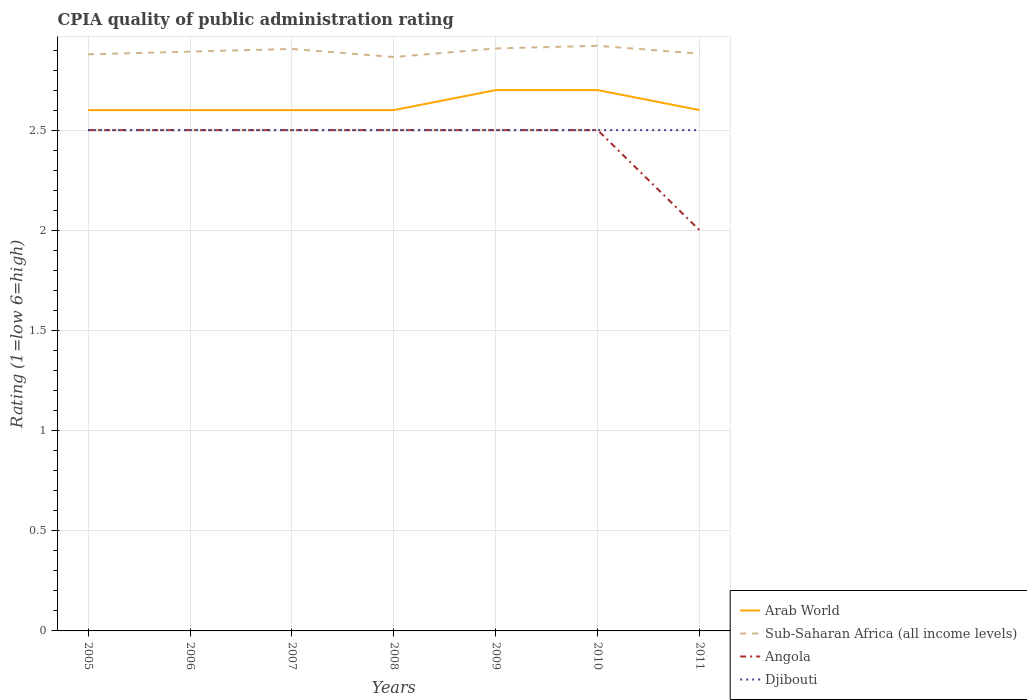How many different coloured lines are there?
Make the answer very short. 4. Is the number of lines equal to the number of legend labels?
Your answer should be compact. Yes. Across all years, what is the maximum CPIA rating in Djibouti?
Offer a very short reply. 2.5. What is the total CPIA rating in Arab World in the graph?
Ensure brevity in your answer.  0. How many lines are there?
Provide a succinct answer. 4. How are the legend labels stacked?
Offer a terse response. Vertical. What is the title of the graph?
Give a very brief answer. CPIA quality of public administration rating. Does "Middle income" appear as one of the legend labels in the graph?
Your response must be concise. No. What is the label or title of the Y-axis?
Give a very brief answer. Rating (1=low 6=high). What is the Rating (1=low 6=high) in Arab World in 2005?
Keep it short and to the point. 2.6. What is the Rating (1=low 6=high) of Sub-Saharan Africa (all income levels) in 2005?
Your answer should be compact. 2.88. What is the Rating (1=low 6=high) of Angola in 2005?
Give a very brief answer. 2.5. What is the Rating (1=low 6=high) of Djibouti in 2005?
Offer a terse response. 2.5. What is the Rating (1=low 6=high) of Arab World in 2006?
Offer a very short reply. 2.6. What is the Rating (1=low 6=high) of Sub-Saharan Africa (all income levels) in 2006?
Offer a very short reply. 2.89. What is the Rating (1=low 6=high) in Sub-Saharan Africa (all income levels) in 2007?
Offer a terse response. 2.91. What is the Rating (1=low 6=high) of Sub-Saharan Africa (all income levels) in 2008?
Your answer should be compact. 2.86. What is the Rating (1=low 6=high) of Angola in 2008?
Give a very brief answer. 2.5. What is the Rating (1=low 6=high) of Djibouti in 2008?
Your answer should be very brief. 2.5. What is the Rating (1=low 6=high) of Sub-Saharan Africa (all income levels) in 2009?
Offer a terse response. 2.91. What is the Rating (1=low 6=high) of Angola in 2009?
Offer a very short reply. 2.5. What is the Rating (1=low 6=high) in Djibouti in 2009?
Offer a terse response. 2.5. What is the Rating (1=low 6=high) of Arab World in 2010?
Your response must be concise. 2.7. What is the Rating (1=low 6=high) in Sub-Saharan Africa (all income levels) in 2010?
Keep it short and to the point. 2.92. What is the Rating (1=low 6=high) in Angola in 2010?
Provide a short and direct response. 2.5. What is the Rating (1=low 6=high) of Arab World in 2011?
Offer a terse response. 2.6. What is the Rating (1=low 6=high) in Sub-Saharan Africa (all income levels) in 2011?
Keep it short and to the point. 2.88. What is the Rating (1=low 6=high) in Djibouti in 2011?
Offer a terse response. 2.5. Across all years, what is the maximum Rating (1=low 6=high) in Sub-Saharan Africa (all income levels)?
Ensure brevity in your answer.  2.92. Across all years, what is the maximum Rating (1=low 6=high) in Djibouti?
Provide a succinct answer. 2.5. Across all years, what is the minimum Rating (1=low 6=high) of Arab World?
Provide a short and direct response. 2.6. Across all years, what is the minimum Rating (1=low 6=high) of Sub-Saharan Africa (all income levels)?
Ensure brevity in your answer.  2.86. What is the total Rating (1=low 6=high) in Sub-Saharan Africa (all income levels) in the graph?
Your answer should be compact. 20.25. What is the difference between the Rating (1=low 6=high) in Sub-Saharan Africa (all income levels) in 2005 and that in 2006?
Provide a succinct answer. -0.01. What is the difference between the Rating (1=low 6=high) in Angola in 2005 and that in 2006?
Your response must be concise. 0. What is the difference between the Rating (1=low 6=high) of Djibouti in 2005 and that in 2006?
Ensure brevity in your answer.  0. What is the difference between the Rating (1=low 6=high) in Sub-Saharan Africa (all income levels) in 2005 and that in 2007?
Your answer should be very brief. -0.03. What is the difference between the Rating (1=low 6=high) of Sub-Saharan Africa (all income levels) in 2005 and that in 2008?
Your answer should be compact. 0.01. What is the difference between the Rating (1=low 6=high) in Angola in 2005 and that in 2008?
Offer a terse response. 0. What is the difference between the Rating (1=low 6=high) of Sub-Saharan Africa (all income levels) in 2005 and that in 2009?
Make the answer very short. -0.03. What is the difference between the Rating (1=low 6=high) in Angola in 2005 and that in 2009?
Offer a terse response. 0. What is the difference between the Rating (1=low 6=high) in Arab World in 2005 and that in 2010?
Your response must be concise. -0.1. What is the difference between the Rating (1=low 6=high) of Sub-Saharan Africa (all income levels) in 2005 and that in 2010?
Your answer should be compact. -0.04. What is the difference between the Rating (1=low 6=high) in Angola in 2005 and that in 2010?
Offer a terse response. 0. What is the difference between the Rating (1=low 6=high) in Djibouti in 2005 and that in 2010?
Ensure brevity in your answer.  0. What is the difference between the Rating (1=low 6=high) in Sub-Saharan Africa (all income levels) in 2005 and that in 2011?
Your answer should be compact. -0. What is the difference between the Rating (1=low 6=high) of Angola in 2005 and that in 2011?
Your answer should be compact. 0.5. What is the difference between the Rating (1=low 6=high) in Djibouti in 2005 and that in 2011?
Provide a succinct answer. 0. What is the difference between the Rating (1=low 6=high) of Arab World in 2006 and that in 2007?
Provide a short and direct response. 0. What is the difference between the Rating (1=low 6=high) in Sub-Saharan Africa (all income levels) in 2006 and that in 2007?
Your answer should be very brief. -0.01. What is the difference between the Rating (1=low 6=high) of Djibouti in 2006 and that in 2007?
Make the answer very short. 0. What is the difference between the Rating (1=low 6=high) of Arab World in 2006 and that in 2008?
Your response must be concise. 0. What is the difference between the Rating (1=low 6=high) of Sub-Saharan Africa (all income levels) in 2006 and that in 2008?
Make the answer very short. 0.03. What is the difference between the Rating (1=low 6=high) in Angola in 2006 and that in 2008?
Make the answer very short. 0. What is the difference between the Rating (1=low 6=high) of Arab World in 2006 and that in 2009?
Ensure brevity in your answer.  -0.1. What is the difference between the Rating (1=low 6=high) in Sub-Saharan Africa (all income levels) in 2006 and that in 2009?
Ensure brevity in your answer.  -0.02. What is the difference between the Rating (1=low 6=high) in Arab World in 2006 and that in 2010?
Make the answer very short. -0.1. What is the difference between the Rating (1=low 6=high) of Sub-Saharan Africa (all income levels) in 2006 and that in 2010?
Your answer should be compact. -0.03. What is the difference between the Rating (1=low 6=high) in Sub-Saharan Africa (all income levels) in 2006 and that in 2011?
Offer a very short reply. 0.01. What is the difference between the Rating (1=low 6=high) in Arab World in 2007 and that in 2008?
Provide a succinct answer. 0. What is the difference between the Rating (1=low 6=high) of Sub-Saharan Africa (all income levels) in 2007 and that in 2008?
Keep it short and to the point. 0.04. What is the difference between the Rating (1=low 6=high) in Sub-Saharan Africa (all income levels) in 2007 and that in 2009?
Your response must be concise. -0. What is the difference between the Rating (1=low 6=high) in Sub-Saharan Africa (all income levels) in 2007 and that in 2010?
Provide a succinct answer. -0.02. What is the difference between the Rating (1=low 6=high) of Angola in 2007 and that in 2010?
Provide a short and direct response. 0. What is the difference between the Rating (1=low 6=high) in Arab World in 2007 and that in 2011?
Offer a very short reply. 0. What is the difference between the Rating (1=low 6=high) in Sub-Saharan Africa (all income levels) in 2007 and that in 2011?
Ensure brevity in your answer.  0.02. What is the difference between the Rating (1=low 6=high) in Djibouti in 2007 and that in 2011?
Your answer should be very brief. 0. What is the difference between the Rating (1=low 6=high) in Arab World in 2008 and that in 2009?
Give a very brief answer. -0.1. What is the difference between the Rating (1=low 6=high) in Sub-Saharan Africa (all income levels) in 2008 and that in 2009?
Ensure brevity in your answer.  -0.04. What is the difference between the Rating (1=low 6=high) in Angola in 2008 and that in 2009?
Make the answer very short. 0. What is the difference between the Rating (1=low 6=high) of Djibouti in 2008 and that in 2009?
Provide a succinct answer. 0. What is the difference between the Rating (1=low 6=high) of Sub-Saharan Africa (all income levels) in 2008 and that in 2010?
Your answer should be very brief. -0.06. What is the difference between the Rating (1=low 6=high) of Angola in 2008 and that in 2010?
Offer a very short reply. 0. What is the difference between the Rating (1=low 6=high) in Arab World in 2008 and that in 2011?
Make the answer very short. 0. What is the difference between the Rating (1=low 6=high) of Sub-Saharan Africa (all income levels) in 2008 and that in 2011?
Provide a short and direct response. -0.02. What is the difference between the Rating (1=low 6=high) of Angola in 2008 and that in 2011?
Give a very brief answer. 0.5. What is the difference between the Rating (1=low 6=high) in Sub-Saharan Africa (all income levels) in 2009 and that in 2010?
Your response must be concise. -0.01. What is the difference between the Rating (1=low 6=high) in Angola in 2009 and that in 2010?
Provide a succinct answer. 0. What is the difference between the Rating (1=low 6=high) in Djibouti in 2009 and that in 2010?
Offer a very short reply. 0. What is the difference between the Rating (1=low 6=high) of Sub-Saharan Africa (all income levels) in 2009 and that in 2011?
Make the answer very short. 0.03. What is the difference between the Rating (1=low 6=high) of Angola in 2009 and that in 2011?
Ensure brevity in your answer.  0.5. What is the difference between the Rating (1=low 6=high) of Sub-Saharan Africa (all income levels) in 2010 and that in 2011?
Give a very brief answer. 0.04. What is the difference between the Rating (1=low 6=high) of Angola in 2010 and that in 2011?
Provide a succinct answer. 0.5. What is the difference between the Rating (1=low 6=high) in Djibouti in 2010 and that in 2011?
Keep it short and to the point. 0. What is the difference between the Rating (1=low 6=high) in Arab World in 2005 and the Rating (1=low 6=high) in Sub-Saharan Africa (all income levels) in 2006?
Offer a very short reply. -0.29. What is the difference between the Rating (1=low 6=high) of Arab World in 2005 and the Rating (1=low 6=high) of Angola in 2006?
Offer a very short reply. 0.1. What is the difference between the Rating (1=low 6=high) of Arab World in 2005 and the Rating (1=low 6=high) of Djibouti in 2006?
Provide a succinct answer. 0.1. What is the difference between the Rating (1=low 6=high) in Sub-Saharan Africa (all income levels) in 2005 and the Rating (1=low 6=high) in Angola in 2006?
Provide a succinct answer. 0.38. What is the difference between the Rating (1=low 6=high) of Sub-Saharan Africa (all income levels) in 2005 and the Rating (1=low 6=high) of Djibouti in 2006?
Your answer should be compact. 0.38. What is the difference between the Rating (1=low 6=high) in Angola in 2005 and the Rating (1=low 6=high) in Djibouti in 2006?
Offer a very short reply. 0. What is the difference between the Rating (1=low 6=high) in Arab World in 2005 and the Rating (1=low 6=high) in Sub-Saharan Africa (all income levels) in 2007?
Provide a short and direct response. -0.31. What is the difference between the Rating (1=low 6=high) in Arab World in 2005 and the Rating (1=low 6=high) in Djibouti in 2007?
Make the answer very short. 0.1. What is the difference between the Rating (1=low 6=high) in Sub-Saharan Africa (all income levels) in 2005 and the Rating (1=low 6=high) in Angola in 2007?
Offer a very short reply. 0.38. What is the difference between the Rating (1=low 6=high) in Sub-Saharan Africa (all income levels) in 2005 and the Rating (1=low 6=high) in Djibouti in 2007?
Provide a short and direct response. 0.38. What is the difference between the Rating (1=low 6=high) of Angola in 2005 and the Rating (1=low 6=high) of Djibouti in 2007?
Your answer should be very brief. 0. What is the difference between the Rating (1=low 6=high) of Arab World in 2005 and the Rating (1=low 6=high) of Sub-Saharan Africa (all income levels) in 2008?
Provide a short and direct response. -0.26. What is the difference between the Rating (1=low 6=high) in Arab World in 2005 and the Rating (1=low 6=high) in Angola in 2008?
Provide a short and direct response. 0.1. What is the difference between the Rating (1=low 6=high) of Sub-Saharan Africa (all income levels) in 2005 and the Rating (1=low 6=high) of Angola in 2008?
Provide a short and direct response. 0.38. What is the difference between the Rating (1=low 6=high) in Sub-Saharan Africa (all income levels) in 2005 and the Rating (1=low 6=high) in Djibouti in 2008?
Offer a very short reply. 0.38. What is the difference between the Rating (1=low 6=high) of Arab World in 2005 and the Rating (1=low 6=high) of Sub-Saharan Africa (all income levels) in 2009?
Give a very brief answer. -0.31. What is the difference between the Rating (1=low 6=high) of Sub-Saharan Africa (all income levels) in 2005 and the Rating (1=low 6=high) of Angola in 2009?
Your answer should be very brief. 0.38. What is the difference between the Rating (1=low 6=high) of Sub-Saharan Africa (all income levels) in 2005 and the Rating (1=low 6=high) of Djibouti in 2009?
Ensure brevity in your answer.  0.38. What is the difference between the Rating (1=low 6=high) in Angola in 2005 and the Rating (1=low 6=high) in Djibouti in 2009?
Provide a short and direct response. 0. What is the difference between the Rating (1=low 6=high) in Arab World in 2005 and the Rating (1=low 6=high) in Sub-Saharan Africa (all income levels) in 2010?
Provide a short and direct response. -0.32. What is the difference between the Rating (1=low 6=high) of Arab World in 2005 and the Rating (1=low 6=high) of Angola in 2010?
Offer a very short reply. 0.1. What is the difference between the Rating (1=low 6=high) in Sub-Saharan Africa (all income levels) in 2005 and the Rating (1=low 6=high) in Angola in 2010?
Provide a succinct answer. 0.38. What is the difference between the Rating (1=low 6=high) of Sub-Saharan Africa (all income levels) in 2005 and the Rating (1=low 6=high) of Djibouti in 2010?
Ensure brevity in your answer.  0.38. What is the difference between the Rating (1=low 6=high) of Arab World in 2005 and the Rating (1=low 6=high) of Sub-Saharan Africa (all income levels) in 2011?
Give a very brief answer. -0.28. What is the difference between the Rating (1=low 6=high) in Arab World in 2005 and the Rating (1=low 6=high) in Angola in 2011?
Your response must be concise. 0.6. What is the difference between the Rating (1=low 6=high) of Arab World in 2005 and the Rating (1=low 6=high) of Djibouti in 2011?
Give a very brief answer. 0.1. What is the difference between the Rating (1=low 6=high) in Sub-Saharan Africa (all income levels) in 2005 and the Rating (1=low 6=high) in Angola in 2011?
Ensure brevity in your answer.  0.88. What is the difference between the Rating (1=low 6=high) in Sub-Saharan Africa (all income levels) in 2005 and the Rating (1=low 6=high) in Djibouti in 2011?
Your answer should be very brief. 0.38. What is the difference between the Rating (1=low 6=high) of Angola in 2005 and the Rating (1=low 6=high) of Djibouti in 2011?
Your response must be concise. 0. What is the difference between the Rating (1=low 6=high) in Arab World in 2006 and the Rating (1=low 6=high) in Sub-Saharan Africa (all income levels) in 2007?
Keep it short and to the point. -0.31. What is the difference between the Rating (1=low 6=high) in Sub-Saharan Africa (all income levels) in 2006 and the Rating (1=low 6=high) in Angola in 2007?
Give a very brief answer. 0.39. What is the difference between the Rating (1=low 6=high) of Sub-Saharan Africa (all income levels) in 2006 and the Rating (1=low 6=high) of Djibouti in 2007?
Give a very brief answer. 0.39. What is the difference between the Rating (1=low 6=high) of Angola in 2006 and the Rating (1=low 6=high) of Djibouti in 2007?
Keep it short and to the point. 0. What is the difference between the Rating (1=low 6=high) in Arab World in 2006 and the Rating (1=low 6=high) in Sub-Saharan Africa (all income levels) in 2008?
Keep it short and to the point. -0.26. What is the difference between the Rating (1=low 6=high) of Arab World in 2006 and the Rating (1=low 6=high) of Djibouti in 2008?
Your response must be concise. 0.1. What is the difference between the Rating (1=low 6=high) in Sub-Saharan Africa (all income levels) in 2006 and the Rating (1=low 6=high) in Angola in 2008?
Give a very brief answer. 0.39. What is the difference between the Rating (1=low 6=high) in Sub-Saharan Africa (all income levels) in 2006 and the Rating (1=low 6=high) in Djibouti in 2008?
Provide a succinct answer. 0.39. What is the difference between the Rating (1=low 6=high) of Arab World in 2006 and the Rating (1=low 6=high) of Sub-Saharan Africa (all income levels) in 2009?
Your answer should be very brief. -0.31. What is the difference between the Rating (1=low 6=high) in Arab World in 2006 and the Rating (1=low 6=high) in Angola in 2009?
Your answer should be very brief. 0.1. What is the difference between the Rating (1=low 6=high) in Arab World in 2006 and the Rating (1=low 6=high) in Djibouti in 2009?
Your answer should be compact. 0.1. What is the difference between the Rating (1=low 6=high) in Sub-Saharan Africa (all income levels) in 2006 and the Rating (1=low 6=high) in Angola in 2009?
Your answer should be compact. 0.39. What is the difference between the Rating (1=low 6=high) in Sub-Saharan Africa (all income levels) in 2006 and the Rating (1=low 6=high) in Djibouti in 2009?
Offer a very short reply. 0.39. What is the difference between the Rating (1=low 6=high) in Arab World in 2006 and the Rating (1=low 6=high) in Sub-Saharan Africa (all income levels) in 2010?
Your answer should be very brief. -0.32. What is the difference between the Rating (1=low 6=high) in Sub-Saharan Africa (all income levels) in 2006 and the Rating (1=low 6=high) in Angola in 2010?
Offer a terse response. 0.39. What is the difference between the Rating (1=low 6=high) in Sub-Saharan Africa (all income levels) in 2006 and the Rating (1=low 6=high) in Djibouti in 2010?
Provide a short and direct response. 0.39. What is the difference between the Rating (1=low 6=high) of Angola in 2006 and the Rating (1=low 6=high) of Djibouti in 2010?
Provide a short and direct response. 0. What is the difference between the Rating (1=low 6=high) of Arab World in 2006 and the Rating (1=low 6=high) of Sub-Saharan Africa (all income levels) in 2011?
Make the answer very short. -0.28. What is the difference between the Rating (1=low 6=high) of Arab World in 2006 and the Rating (1=low 6=high) of Angola in 2011?
Offer a very short reply. 0.6. What is the difference between the Rating (1=low 6=high) in Arab World in 2006 and the Rating (1=low 6=high) in Djibouti in 2011?
Keep it short and to the point. 0.1. What is the difference between the Rating (1=low 6=high) in Sub-Saharan Africa (all income levels) in 2006 and the Rating (1=low 6=high) in Angola in 2011?
Your answer should be very brief. 0.89. What is the difference between the Rating (1=low 6=high) in Sub-Saharan Africa (all income levels) in 2006 and the Rating (1=low 6=high) in Djibouti in 2011?
Provide a short and direct response. 0.39. What is the difference between the Rating (1=low 6=high) of Angola in 2006 and the Rating (1=low 6=high) of Djibouti in 2011?
Ensure brevity in your answer.  0. What is the difference between the Rating (1=low 6=high) of Arab World in 2007 and the Rating (1=low 6=high) of Sub-Saharan Africa (all income levels) in 2008?
Your response must be concise. -0.26. What is the difference between the Rating (1=low 6=high) in Arab World in 2007 and the Rating (1=low 6=high) in Djibouti in 2008?
Make the answer very short. 0.1. What is the difference between the Rating (1=low 6=high) of Sub-Saharan Africa (all income levels) in 2007 and the Rating (1=low 6=high) of Angola in 2008?
Offer a very short reply. 0.41. What is the difference between the Rating (1=low 6=high) in Sub-Saharan Africa (all income levels) in 2007 and the Rating (1=low 6=high) in Djibouti in 2008?
Make the answer very short. 0.41. What is the difference between the Rating (1=low 6=high) of Angola in 2007 and the Rating (1=low 6=high) of Djibouti in 2008?
Your response must be concise. 0. What is the difference between the Rating (1=low 6=high) in Arab World in 2007 and the Rating (1=low 6=high) in Sub-Saharan Africa (all income levels) in 2009?
Your answer should be compact. -0.31. What is the difference between the Rating (1=low 6=high) of Arab World in 2007 and the Rating (1=low 6=high) of Angola in 2009?
Offer a very short reply. 0.1. What is the difference between the Rating (1=low 6=high) of Arab World in 2007 and the Rating (1=low 6=high) of Djibouti in 2009?
Offer a very short reply. 0.1. What is the difference between the Rating (1=low 6=high) in Sub-Saharan Africa (all income levels) in 2007 and the Rating (1=low 6=high) in Angola in 2009?
Your response must be concise. 0.41. What is the difference between the Rating (1=low 6=high) in Sub-Saharan Africa (all income levels) in 2007 and the Rating (1=low 6=high) in Djibouti in 2009?
Provide a succinct answer. 0.41. What is the difference between the Rating (1=low 6=high) of Arab World in 2007 and the Rating (1=low 6=high) of Sub-Saharan Africa (all income levels) in 2010?
Your answer should be compact. -0.32. What is the difference between the Rating (1=low 6=high) in Arab World in 2007 and the Rating (1=low 6=high) in Djibouti in 2010?
Make the answer very short. 0.1. What is the difference between the Rating (1=low 6=high) in Sub-Saharan Africa (all income levels) in 2007 and the Rating (1=low 6=high) in Angola in 2010?
Make the answer very short. 0.41. What is the difference between the Rating (1=low 6=high) in Sub-Saharan Africa (all income levels) in 2007 and the Rating (1=low 6=high) in Djibouti in 2010?
Offer a very short reply. 0.41. What is the difference between the Rating (1=low 6=high) in Arab World in 2007 and the Rating (1=low 6=high) in Sub-Saharan Africa (all income levels) in 2011?
Make the answer very short. -0.28. What is the difference between the Rating (1=low 6=high) in Sub-Saharan Africa (all income levels) in 2007 and the Rating (1=low 6=high) in Angola in 2011?
Make the answer very short. 0.91. What is the difference between the Rating (1=low 6=high) of Sub-Saharan Africa (all income levels) in 2007 and the Rating (1=low 6=high) of Djibouti in 2011?
Offer a terse response. 0.41. What is the difference between the Rating (1=low 6=high) in Arab World in 2008 and the Rating (1=low 6=high) in Sub-Saharan Africa (all income levels) in 2009?
Keep it short and to the point. -0.31. What is the difference between the Rating (1=low 6=high) of Arab World in 2008 and the Rating (1=low 6=high) of Angola in 2009?
Your answer should be compact. 0.1. What is the difference between the Rating (1=low 6=high) of Arab World in 2008 and the Rating (1=low 6=high) of Djibouti in 2009?
Offer a very short reply. 0.1. What is the difference between the Rating (1=low 6=high) in Sub-Saharan Africa (all income levels) in 2008 and the Rating (1=low 6=high) in Angola in 2009?
Make the answer very short. 0.36. What is the difference between the Rating (1=low 6=high) in Sub-Saharan Africa (all income levels) in 2008 and the Rating (1=low 6=high) in Djibouti in 2009?
Give a very brief answer. 0.36. What is the difference between the Rating (1=low 6=high) in Arab World in 2008 and the Rating (1=low 6=high) in Sub-Saharan Africa (all income levels) in 2010?
Your response must be concise. -0.32. What is the difference between the Rating (1=low 6=high) in Arab World in 2008 and the Rating (1=low 6=high) in Djibouti in 2010?
Offer a terse response. 0.1. What is the difference between the Rating (1=low 6=high) in Sub-Saharan Africa (all income levels) in 2008 and the Rating (1=low 6=high) in Angola in 2010?
Ensure brevity in your answer.  0.36. What is the difference between the Rating (1=low 6=high) of Sub-Saharan Africa (all income levels) in 2008 and the Rating (1=low 6=high) of Djibouti in 2010?
Give a very brief answer. 0.36. What is the difference between the Rating (1=low 6=high) in Angola in 2008 and the Rating (1=low 6=high) in Djibouti in 2010?
Your answer should be very brief. 0. What is the difference between the Rating (1=low 6=high) in Arab World in 2008 and the Rating (1=low 6=high) in Sub-Saharan Africa (all income levels) in 2011?
Your answer should be very brief. -0.28. What is the difference between the Rating (1=low 6=high) in Arab World in 2008 and the Rating (1=low 6=high) in Angola in 2011?
Your answer should be very brief. 0.6. What is the difference between the Rating (1=low 6=high) of Sub-Saharan Africa (all income levels) in 2008 and the Rating (1=low 6=high) of Angola in 2011?
Keep it short and to the point. 0.86. What is the difference between the Rating (1=low 6=high) in Sub-Saharan Africa (all income levels) in 2008 and the Rating (1=low 6=high) in Djibouti in 2011?
Provide a succinct answer. 0.36. What is the difference between the Rating (1=low 6=high) in Angola in 2008 and the Rating (1=low 6=high) in Djibouti in 2011?
Provide a short and direct response. 0. What is the difference between the Rating (1=low 6=high) of Arab World in 2009 and the Rating (1=low 6=high) of Sub-Saharan Africa (all income levels) in 2010?
Your response must be concise. -0.22. What is the difference between the Rating (1=low 6=high) in Arab World in 2009 and the Rating (1=low 6=high) in Djibouti in 2010?
Offer a terse response. 0.2. What is the difference between the Rating (1=low 6=high) of Sub-Saharan Africa (all income levels) in 2009 and the Rating (1=low 6=high) of Angola in 2010?
Your answer should be very brief. 0.41. What is the difference between the Rating (1=low 6=high) of Sub-Saharan Africa (all income levels) in 2009 and the Rating (1=low 6=high) of Djibouti in 2010?
Your answer should be compact. 0.41. What is the difference between the Rating (1=low 6=high) in Angola in 2009 and the Rating (1=low 6=high) in Djibouti in 2010?
Your response must be concise. 0. What is the difference between the Rating (1=low 6=high) of Arab World in 2009 and the Rating (1=low 6=high) of Sub-Saharan Africa (all income levels) in 2011?
Give a very brief answer. -0.18. What is the difference between the Rating (1=low 6=high) in Arab World in 2009 and the Rating (1=low 6=high) in Angola in 2011?
Your answer should be very brief. 0.7. What is the difference between the Rating (1=low 6=high) in Sub-Saharan Africa (all income levels) in 2009 and the Rating (1=low 6=high) in Angola in 2011?
Your answer should be very brief. 0.91. What is the difference between the Rating (1=low 6=high) in Sub-Saharan Africa (all income levels) in 2009 and the Rating (1=low 6=high) in Djibouti in 2011?
Offer a very short reply. 0.41. What is the difference between the Rating (1=low 6=high) of Arab World in 2010 and the Rating (1=low 6=high) of Sub-Saharan Africa (all income levels) in 2011?
Offer a very short reply. -0.18. What is the difference between the Rating (1=low 6=high) of Arab World in 2010 and the Rating (1=low 6=high) of Djibouti in 2011?
Provide a succinct answer. 0.2. What is the difference between the Rating (1=low 6=high) of Sub-Saharan Africa (all income levels) in 2010 and the Rating (1=low 6=high) of Angola in 2011?
Provide a succinct answer. 0.92. What is the difference between the Rating (1=low 6=high) in Sub-Saharan Africa (all income levels) in 2010 and the Rating (1=low 6=high) in Djibouti in 2011?
Provide a succinct answer. 0.42. What is the difference between the Rating (1=low 6=high) in Angola in 2010 and the Rating (1=low 6=high) in Djibouti in 2011?
Make the answer very short. 0. What is the average Rating (1=low 6=high) in Arab World per year?
Your response must be concise. 2.63. What is the average Rating (1=low 6=high) of Sub-Saharan Africa (all income levels) per year?
Make the answer very short. 2.89. What is the average Rating (1=low 6=high) in Angola per year?
Offer a very short reply. 2.43. What is the average Rating (1=low 6=high) in Djibouti per year?
Offer a very short reply. 2.5. In the year 2005, what is the difference between the Rating (1=low 6=high) of Arab World and Rating (1=low 6=high) of Sub-Saharan Africa (all income levels)?
Make the answer very short. -0.28. In the year 2005, what is the difference between the Rating (1=low 6=high) of Sub-Saharan Africa (all income levels) and Rating (1=low 6=high) of Angola?
Offer a very short reply. 0.38. In the year 2005, what is the difference between the Rating (1=low 6=high) in Sub-Saharan Africa (all income levels) and Rating (1=low 6=high) in Djibouti?
Provide a succinct answer. 0.38. In the year 2006, what is the difference between the Rating (1=low 6=high) in Arab World and Rating (1=low 6=high) in Sub-Saharan Africa (all income levels)?
Give a very brief answer. -0.29. In the year 2006, what is the difference between the Rating (1=low 6=high) in Arab World and Rating (1=low 6=high) in Angola?
Make the answer very short. 0.1. In the year 2006, what is the difference between the Rating (1=low 6=high) of Sub-Saharan Africa (all income levels) and Rating (1=low 6=high) of Angola?
Provide a succinct answer. 0.39. In the year 2006, what is the difference between the Rating (1=low 6=high) in Sub-Saharan Africa (all income levels) and Rating (1=low 6=high) in Djibouti?
Keep it short and to the point. 0.39. In the year 2007, what is the difference between the Rating (1=low 6=high) in Arab World and Rating (1=low 6=high) in Sub-Saharan Africa (all income levels)?
Provide a succinct answer. -0.31. In the year 2007, what is the difference between the Rating (1=low 6=high) in Arab World and Rating (1=low 6=high) in Angola?
Make the answer very short. 0.1. In the year 2007, what is the difference between the Rating (1=low 6=high) in Sub-Saharan Africa (all income levels) and Rating (1=low 6=high) in Angola?
Provide a short and direct response. 0.41. In the year 2007, what is the difference between the Rating (1=low 6=high) of Sub-Saharan Africa (all income levels) and Rating (1=low 6=high) of Djibouti?
Make the answer very short. 0.41. In the year 2007, what is the difference between the Rating (1=low 6=high) in Angola and Rating (1=low 6=high) in Djibouti?
Your answer should be very brief. 0. In the year 2008, what is the difference between the Rating (1=low 6=high) in Arab World and Rating (1=low 6=high) in Sub-Saharan Africa (all income levels)?
Ensure brevity in your answer.  -0.26. In the year 2008, what is the difference between the Rating (1=low 6=high) of Arab World and Rating (1=low 6=high) of Angola?
Provide a succinct answer. 0.1. In the year 2008, what is the difference between the Rating (1=low 6=high) in Sub-Saharan Africa (all income levels) and Rating (1=low 6=high) in Angola?
Ensure brevity in your answer.  0.36. In the year 2008, what is the difference between the Rating (1=low 6=high) of Sub-Saharan Africa (all income levels) and Rating (1=low 6=high) of Djibouti?
Your answer should be compact. 0.36. In the year 2009, what is the difference between the Rating (1=low 6=high) of Arab World and Rating (1=low 6=high) of Sub-Saharan Africa (all income levels)?
Offer a very short reply. -0.21. In the year 2009, what is the difference between the Rating (1=low 6=high) in Sub-Saharan Africa (all income levels) and Rating (1=low 6=high) in Angola?
Offer a very short reply. 0.41. In the year 2009, what is the difference between the Rating (1=low 6=high) of Sub-Saharan Africa (all income levels) and Rating (1=low 6=high) of Djibouti?
Provide a succinct answer. 0.41. In the year 2010, what is the difference between the Rating (1=low 6=high) in Arab World and Rating (1=low 6=high) in Sub-Saharan Africa (all income levels)?
Provide a short and direct response. -0.22. In the year 2010, what is the difference between the Rating (1=low 6=high) of Arab World and Rating (1=low 6=high) of Djibouti?
Your response must be concise. 0.2. In the year 2010, what is the difference between the Rating (1=low 6=high) in Sub-Saharan Africa (all income levels) and Rating (1=low 6=high) in Angola?
Keep it short and to the point. 0.42. In the year 2010, what is the difference between the Rating (1=low 6=high) of Sub-Saharan Africa (all income levels) and Rating (1=low 6=high) of Djibouti?
Ensure brevity in your answer.  0.42. In the year 2010, what is the difference between the Rating (1=low 6=high) of Angola and Rating (1=low 6=high) of Djibouti?
Your answer should be very brief. 0. In the year 2011, what is the difference between the Rating (1=low 6=high) in Arab World and Rating (1=low 6=high) in Sub-Saharan Africa (all income levels)?
Offer a very short reply. -0.28. In the year 2011, what is the difference between the Rating (1=low 6=high) of Sub-Saharan Africa (all income levels) and Rating (1=low 6=high) of Angola?
Keep it short and to the point. 0.88. In the year 2011, what is the difference between the Rating (1=low 6=high) of Sub-Saharan Africa (all income levels) and Rating (1=low 6=high) of Djibouti?
Keep it short and to the point. 0.38. What is the ratio of the Rating (1=low 6=high) in Angola in 2005 to that in 2006?
Keep it short and to the point. 1. What is the ratio of the Rating (1=low 6=high) of Djibouti in 2005 to that in 2006?
Make the answer very short. 1. What is the ratio of the Rating (1=low 6=high) in Arab World in 2005 to that in 2007?
Give a very brief answer. 1. What is the ratio of the Rating (1=low 6=high) in Angola in 2005 to that in 2007?
Offer a terse response. 1. What is the ratio of the Rating (1=low 6=high) in Djibouti in 2005 to that in 2007?
Provide a succinct answer. 1. What is the ratio of the Rating (1=low 6=high) of Angola in 2005 to that in 2008?
Offer a very short reply. 1. What is the ratio of the Rating (1=low 6=high) of Djibouti in 2005 to that in 2008?
Your answer should be compact. 1. What is the ratio of the Rating (1=low 6=high) in Sub-Saharan Africa (all income levels) in 2005 to that in 2009?
Offer a very short reply. 0.99. What is the ratio of the Rating (1=low 6=high) in Angola in 2005 to that in 2009?
Give a very brief answer. 1. What is the ratio of the Rating (1=low 6=high) of Arab World in 2005 to that in 2010?
Your answer should be compact. 0.96. What is the ratio of the Rating (1=low 6=high) of Sub-Saharan Africa (all income levels) in 2005 to that in 2010?
Provide a succinct answer. 0.99. What is the ratio of the Rating (1=low 6=high) in Angola in 2005 to that in 2010?
Provide a short and direct response. 1. What is the ratio of the Rating (1=low 6=high) in Djibouti in 2005 to that in 2010?
Offer a terse response. 1. What is the ratio of the Rating (1=low 6=high) of Arab World in 2005 to that in 2011?
Offer a terse response. 1. What is the ratio of the Rating (1=low 6=high) in Angola in 2005 to that in 2011?
Keep it short and to the point. 1.25. What is the ratio of the Rating (1=low 6=high) in Djibouti in 2005 to that in 2011?
Keep it short and to the point. 1. What is the ratio of the Rating (1=low 6=high) of Arab World in 2006 to that in 2007?
Provide a short and direct response. 1. What is the ratio of the Rating (1=low 6=high) in Angola in 2006 to that in 2007?
Make the answer very short. 1. What is the ratio of the Rating (1=low 6=high) of Sub-Saharan Africa (all income levels) in 2006 to that in 2008?
Offer a very short reply. 1.01. What is the ratio of the Rating (1=low 6=high) in Angola in 2006 to that in 2008?
Offer a very short reply. 1. What is the ratio of the Rating (1=low 6=high) in Arab World in 2006 to that in 2009?
Give a very brief answer. 0.96. What is the ratio of the Rating (1=low 6=high) in Sub-Saharan Africa (all income levels) in 2006 to that in 2009?
Offer a terse response. 0.99. What is the ratio of the Rating (1=low 6=high) of Sub-Saharan Africa (all income levels) in 2006 to that in 2010?
Offer a very short reply. 0.99. What is the ratio of the Rating (1=low 6=high) in Angola in 2006 to that in 2010?
Make the answer very short. 1. What is the ratio of the Rating (1=low 6=high) of Djibouti in 2006 to that in 2010?
Your answer should be compact. 1. What is the ratio of the Rating (1=low 6=high) of Arab World in 2006 to that in 2011?
Your response must be concise. 1. What is the ratio of the Rating (1=low 6=high) in Arab World in 2007 to that in 2008?
Make the answer very short. 1. What is the ratio of the Rating (1=low 6=high) of Sub-Saharan Africa (all income levels) in 2007 to that in 2008?
Your answer should be compact. 1.01. What is the ratio of the Rating (1=low 6=high) of Angola in 2007 to that in 2008?
Your answer should be compact. 1. What is the ratio of the Rating (1=low 6=high) in Arab World in 2007 to that in 2009?
Provide a short and direct response. 0.96. What is the ratio of the Rating (1=low 6=high) of Angola in 2007 to that in 2009?
Your response must be concise. 1. What is the ratio of the Rating (1=low 6=high) of Djibouti in 2007 to that in 2009?
Provide a short and direct response. 1. What is the ratio of the Rating (1=low 6=high) of Arab World in 2007 to that in 2010?
Provide a succinct answer. 0.96. What is the ratio of the Rating (1=low 6=high) in Sub-Saharan Africa (all income levels) in 2007 to that in 2010?
Your response must be concise. 0.99. What is the ratio of the Rating (1=low 6=high) in Arab World in 2007 to that in 2011?
Offer a very short reply. 1. What is the ratio of the Rating (1=low 6=high) of Sub-Saharan Africa (all income levels) in 2007 to that in 2011?
Give a very brief answer. 1.01. What is the ratio of the Rating (1=low 6=high) of Angola in 2007 to that in 2011?
Ensure brevity in your answer.  1.25. What is the ratio of the Rating (1=low 6=high) of Sub-Saharan Africa (all income levels) in 2008 to that in 2009?
Keep it short and to the point. 0.99. What is the ratio of the Rating (1=low 6=high) in Angola in 2008 to that in 2009?
Provide a succinct answer. 1. What is the ratio of the Rating (1=low 6=high) of Djibouti in 2008 to that in 2009?
Your answer should be compact. 1. What is the ratio of the Rating (1=low 6=high) of Arab World in 2008 to that in 2010?
Offer a terse response. 0.96. What is the ratio of the Rating (1=low 6=high) in Sub-Saharan Africa (all income levels) in 2008 to that in 2010?
Provide a succinct answer. 0.98. What is the ratio of the Rating (1=low 6=high) of Angola in 2008 to that in 2010?
Provide a succinct answer. 1. What is the ratio of the Rating (1=low 6=high) of Djibouti in 2008 to that in 2010?
Your answer should be compact. 1. What is the ratio of the Rating (1=low 6=high) of Arab World in 2008 to that in 2011?
Provide a short and direct response. 1. What is the ratio of the Rating (1=low 6=high) in Sub-Saharan Africa (all income levels) in 2008 to that in 2011?
Offer a terse response. 0.99. What is the ratio of the Rating (1=low 6=high) of Djibouti in 2008 to that in 2011?
Keep it short and to the point. 1. What is the ratio of the Rating (1=low 6=high) in Arab World in 2009 to that in 2010?
Offer a terse response. 1. What is the ratio of the Rating (1=low 6=high) of Sub-Saharan Africa (all income levels) in 2009 to that in 2010?
Offer a terse response. 1. What is the ratio of the Rating (1=low 6=high) of Arab World in 2009 to that in 2011?
Provide a short and direct response. 1.04. What is the ratio of the Rating (1=low 6=high) in Sub-Saharan Africa (all income levels) in 2009 to that in 2011?
Give a very brief answer. 1.01. What is the ratio of the Rating (1=low 6=high) of Djibouti in 2009 to that in 2011?
Make the answer very short. 1. What is the ratio of the Rating (1=low 6=high) of Arab World in 2010 to that in 2011?
Offer a very short reply. 1.04. What is the ratio of the Rating (1=low 6=high) of Sub-Saharan Africa (all income levels) in 2010 to that in 2011?
Ensure brevity in your answer.  1.01. What is the ratio of the Rating (1=low 6=high) in Djibouti in 2010 to that in 2011?
Provide a short and direct response. 1. What is the difference between the highest and the second highest Rating (1=low 6=high) of Arab World?
Your answer should be compact. 0. What is the difference between the highest and the second highest Rating (1=low 6=high) of Sub-Saharan Africa (all income levels)?
Give a very brief answer. 0.01. What is the difference between the highest and the second highest Rating (1=low 6=high) in Djibouti?
Your answer should be compact. 0. What is the difference between the highest and the lowest Rating (1=low 6=high) in Arab World?
Make the answer very short. 0.1. What is the difference between the highest and the lowest Rating (1=low 6=high) of Sub-Saharan Africa (all income levels)?
Keep it short and to the point. 0.06. 